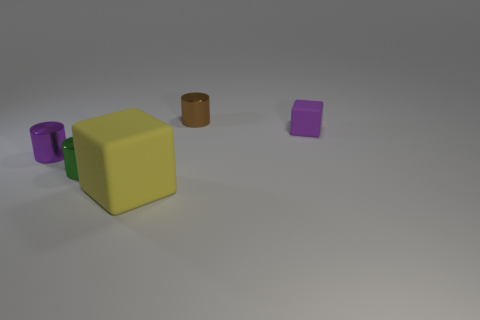What shape is the rubber thing that is behind the small green metallic cylinder?
Offer a terse response. Cube. What size is the purple thing that is made of the same material as the yellow thing?
Ensure brevity in your answer.  Small. What is the shape of the small thing that is both right of the yellow thing and on the left side of the small purple matte object?
Your answer should be compact. Cylinder. Is the color of the cube behind the small green cylinder the same as the large matte thing?
Your response must be concise. No. There is a purple object that is left of the large matte cube; is its shape the same as the purple object that is to the right of the large object?
Give a very brief answer. No. There is a purple object left of the yellow thing; what is its size?
Offer a terse response. Small. What is the size of the shiny cylinder that is on the left side of the green shiny object in front of the purple metallic cylinder?
Offer a very short reply. Small. Is the number of purple rubber things greater than the number of large red shiny spheres?
Your response must be concise. Yes. Are there more tiny brown cylinders that are in front of the tiny green object than tiny purple metallic cylinders that are to the right of the yellow block?
Provide a succinct answer. No. What is the size of the object that is both in front of the purple cylinder and behind the big rubber thing?
Offer a terse response. Small. 